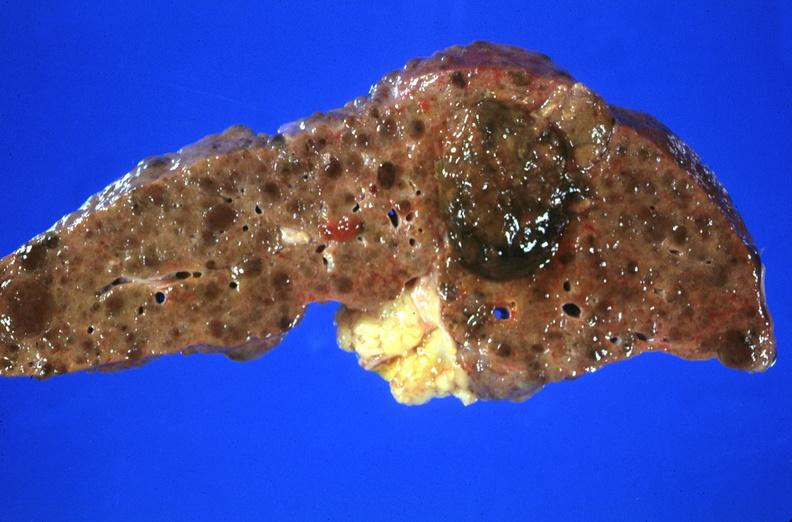s hepatobiliary present?
Answer the question using a single word or phrase. Yes 